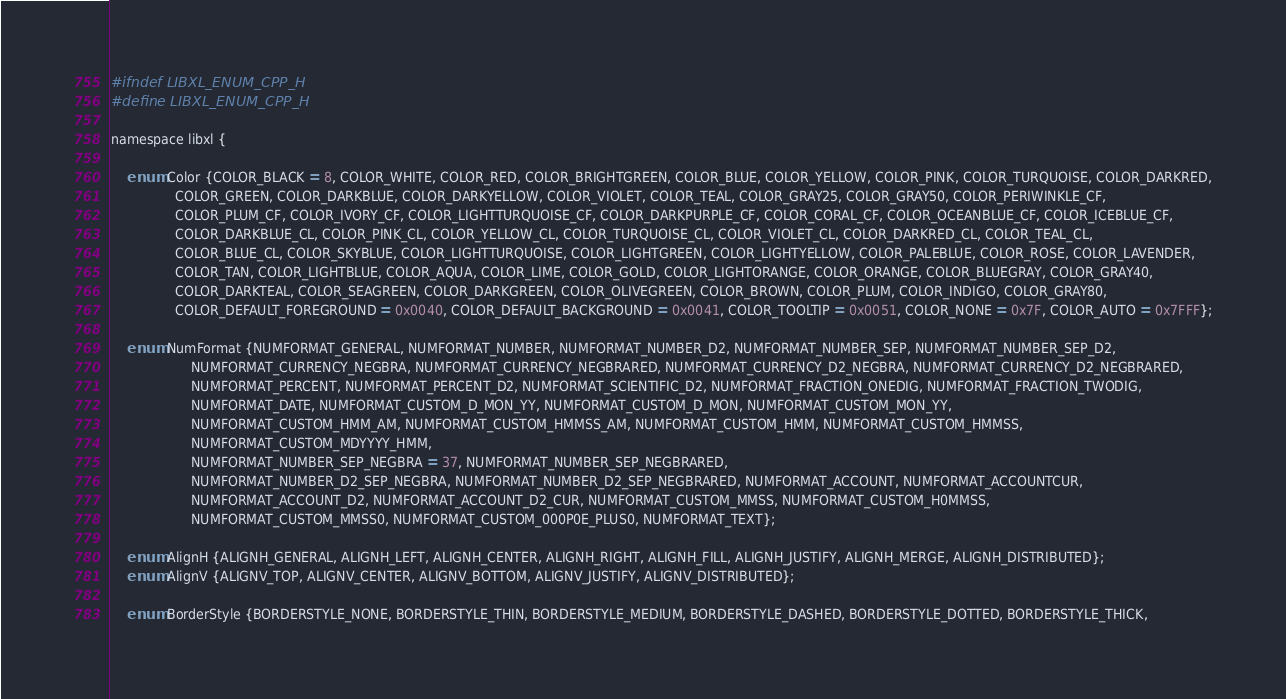Convert code to text. <code><loc_0><loc_0><loc_500><loc_500><_C_>#ifndef LIBXL_ENUM_CPP_H
#define LIBXL_ENUM_CPP_H

namespace libxl {

    enum Color {COLOR_BLACK = 8, COLOR_WHITE, COLOR_RED, COLOR_BRIGHTGREEN, COLOR_BLUE, COLOR_YELLOW, COLOR_PINK, COLOR_TURQUOISE, COLOR_DARKRED,
                COLOR_GREEN, COLOR_DARKBLUE, COLOR_DARKYELLOW, COLOR_VIOLET, COLOR_TEAL, COLOR_GRAY25, COLOR_GRAY50, COLOR_PERIWINKLE_CF,
                COLOR_PLUM_CF, COLOR_IVORY_CF, COLOR_LIGHTTURQUOISE_CF, COLOR_DARKPURPLE_CF, COLOR_CORAL_CF, COLOR_OCEANBLUE_CF, COLOR_ICEBLUE_CF,
                COLOR_DARKBLUE_CL, COLOR_PINK_CL, COLOR_YELLOW_CL, COLOR_TURQUOISE_CL, COLOR_VIOLET_CL, COLOR_DARKRED_CL, COLOR_TEAL_CL,
                COLOR_BLUE_CL, COLOR_SKYBLUE, COLOR_LIGHTTURQUOISE, COLOR_LIGHTGREEN, COLOR_LIGHTYELLOW, COLOR_PALEBLUE, COLOR_ROSE, COLOR_LAVENDER,
                COLOR_TAN, COLOR_LIGHTBLUE, COLOR_AQUA, COLOR_LIME, COLOR_GOLD, COLOR_LIGHTORANGE, COLOR_ORANGE, COLOR_BLUEGRAY, COLOR_GRAY40,
                COLOR_DARKTEAL, COLOR_SEAGREEN, COLOR_DARKGREEN, COLOR_OLIVEGREEN, COLOR_BROWN, COLOR_PLUM, COLOR_INDIGO, COLOR_GRAY80,
                COLOR_DEFAULT_FOREGROUND = 0x0040, COLOR_DEFAULT_BACKGROUND = 0x0041, COLOR_TOOLTIP = 0x0051, COLOR_NONE = 0x7F, COLOR_AUTO = 0x7FFF};

    enum NumFormat {NUMFORMAT_GENERAL, NUMFORMAT_NUMBER, NUMFORMAT_NUMBER_D2, NUMFORMAT_NUMBER_SEP, NUMFORMAT_NUMBER_SEP_D2,
                    NUMFORMAT_CURRENCY_NEGBRA, NUMFORMAT_CURRENCY_NEGBRARED, NUMFORMAT_CURRENCY_D2_NEGBRA, NUMFORMAT_CURRENCY_D2_NEGBRARED,
                    NUMFORMAT_PERCENT, NUMFORMAT_PERCENT_D2, NUMFORMAT_SCIENTIFIC_D2, NUMFORMAT_FRACTION_ONEDIG, NUMFORMAT_FRACTION_TWODIG,
                    NUMFORMAT_DATE, NUMFORMAT_CUSTOM_D_MON_YY, NUMFORMAT_CUSTOM_D_MON, NUMFORMAT_CUSTOM_MON_YY,
                    NUMFORMAT_CUSTOM_HMM_AM, NUMFORMAT_CUSTOM_HMMSS_AM, NUMFORMAT_CUSTOM_HMM, NUMFORMAT_CUSTOM_HMMSS,
                    NUMFORMAT_CUSTOM_MDYYYY_HMM,
                    NUMFORMAT_NUMBER_SEP_NEGBRA = 37, NUMFORMAT_NUMBER_SEP_NEGBRARED,
                    NUMFORMAT_NUMBER_D2_SEP_NEGBRA, NUMFORMAT_NUMBER_D2_SEP_NEGBRARED, NUMFORMAT_ACCOUNT, NUMFORMAT_ACCOUNTCUR,
                    NUMFORMAT_ACCOUNT_D2, NUMFORMAT_ACCOUNT_D2_CUR, NUMFORMAT_CUSTOM_MMSS, NUMFORMAT_CUSTOM_H0MMSS,
                    NUMFORMAT_CUSTOM_MMSS0, NUMFORMAT_CUSTOM_000P0E_PLUS0, NUMFORMAT_TEXT};

    enum AlignH {ALIGNH_GENERAL, ALIGNH_LEFT, ALIGNH_CENTER, ALIGNH_RIGHT, ALIGNH_FILL, ALIGNH_JUSTIFY, ALIGNH_MERGE, ALIGNH_DISTRIBUTED};
    enum AlignV {ALIGNV_TOP, ALIGNV_CENTER, ALIGNV_BOTTOM, ALIGNV_JUSTIFY, ALIGNV_DISTRIBUTED};

    enum BorderStyle {BORDERSTYLE_NONE, BORDERSTYLE_THIN, BORDERSTYLE_MEDIUM, BORDERSTYLE_DASHED, BORDERSTYLE_DOTTED, BORDERSTYLE_THICK,</code> 